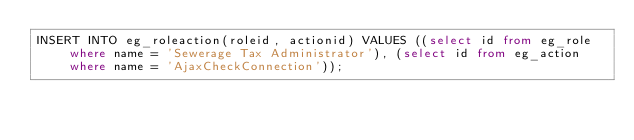<code> <loc_0><loc_0><loc_500><loc_500><_SQL_>INSERT INTO eg_roleaction(roleid, actionid) VALUES ((select id from eg_role where name = 'Sewerage Tax Administrator'), (select id from eg_action where name = 'AjaxCheckConnection'));
</code> 